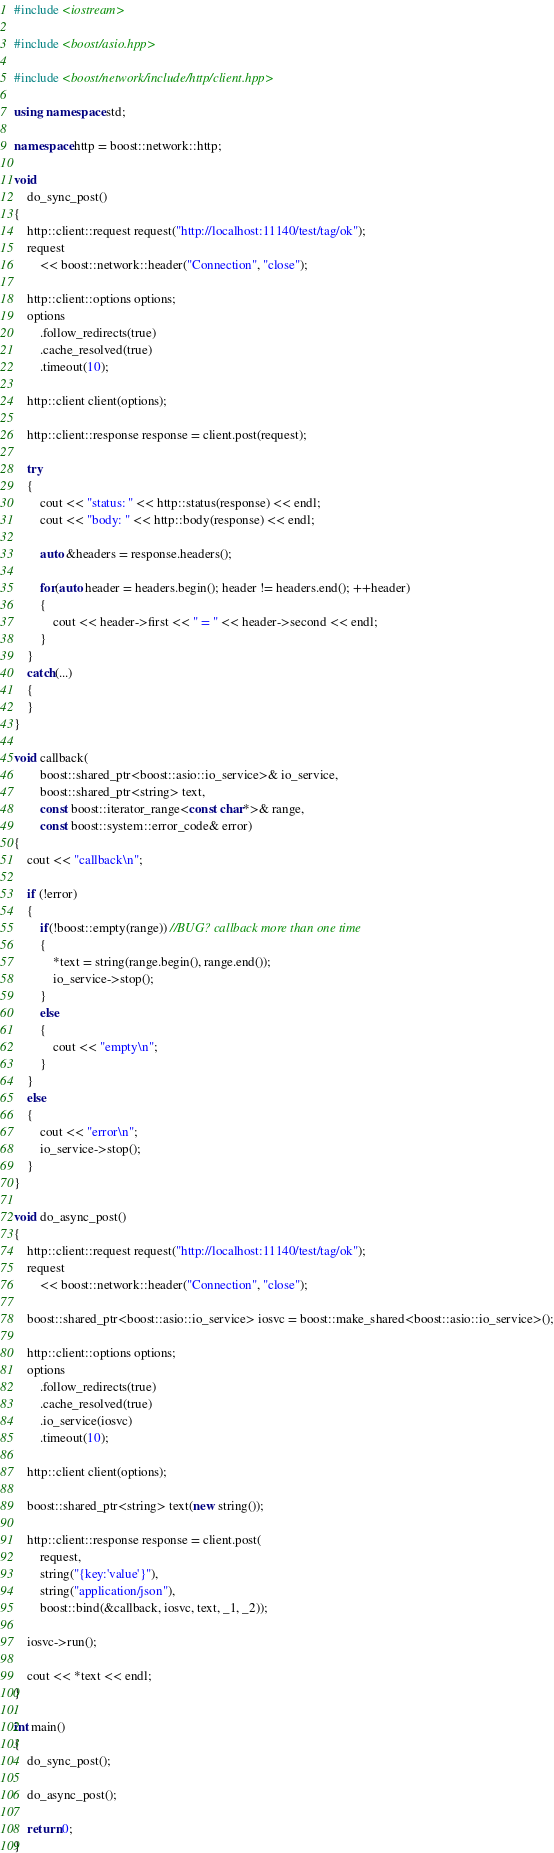<code> <loc_0><loc_0><loc_500><loc_500><_C++_>#include <iostream>

#include <boost/asio.hpp>

#include <boost/network/include/http/client.hpp>

using namespace std;

namespace http = boost::network::http;

void
    do_sync_post()
{
    http::client::request request("http://localhost:11140/test/tag/ok");
    request
        << boost::network::header("Connection", "close");

    http::client::options options;
    options
        .follow_redirects(true)
        .cache_resolved(true)
        .timeout(10);

    http::client client(options);

    http::client::response response = client.post(request);

    try
    {
        cout << "status: " << http::status(response) << endl;
        cout << "body: " << http::body(response) << endl;

        auto &headers = response.headers();

        for(auto header = headers.begin(); header != headers.end(); ++header)
        {
            cout << header->first << " = " << header->second << endl;
        }
    }
    catch(...)
    {
    }
}

void callback(
        boost::shared_ptr<boost::asio::io_service>& io_service,
        boost::shared_ptr<string> text,
        const boost::iterator_range<const char*>& range,
        const boost::system::error_code& error)
{
    cout << "callback\n";

    if (!error)
    {
        if(!boost::empty(range)) //BUG? callback more than one time
        {
            *text = string(range.begin(), range.end());
            io_service->stop();
        }
        else
        {
            cout << "empty\n";
        }
    }
    else
    {
        cout << "error\n";
        io_service->stop();
    }
}

void do_async_post()
{
    http::client::request request("http://localhost:11140/test/tag/ok");
    request
        << boost::network::header("Connection", "close");

    boost::shared_ptr<boost::asio::io_service> iosvc = boost::make_shared<boost::asio::io_service>();

    http::client::options options;
    options
        .follow_redirects(true)
        .cache_resolved(true)
        .io_service(iosvc)
        .timeout(10);

    http::client client(options);

    boost::shared_ptr<string> text(new string());

    http::client::response response = client.post(
        request,
        string("{key:'value'}"),
        string("application/json"),
        boost::bind(&callback, iosvc, text, _1, _2));

    iosvc->run();

    cout << *text << endl;
}

int main()
{
	do_sync_post();

    do_async_post();

	return 0;
}
</code> 